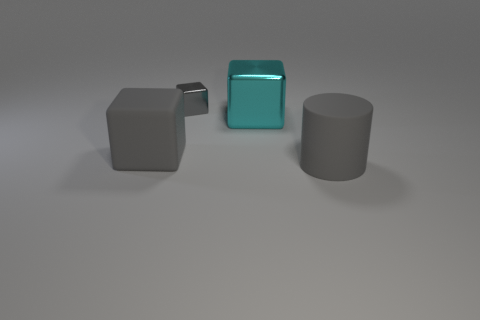Subtract all gray blocks. How many blocks are left? 1 Add 4 small purple cylinders. How many objects exist? 8 Subtract all gray cubes. How many cubes are left? 1 Subtract 1 cubes. How many cubes are left? 2 Subtract all cubes. How many objects are left? 1 Subtract all blue blocks. Subtract all yellow spheres. How many blocks are left? 3 Subtract all cyan cylinders. How many cyan blocks are left? 1 Subtract all large rubber cylinders. Subtract all large purple spheres. How many objects are left? 3 Add 1 tiny gray metallic blocks. How many tiny gray metallic blocks are left? 2 Add 3 gray cylinders. How many gray cylinders exist? 4 